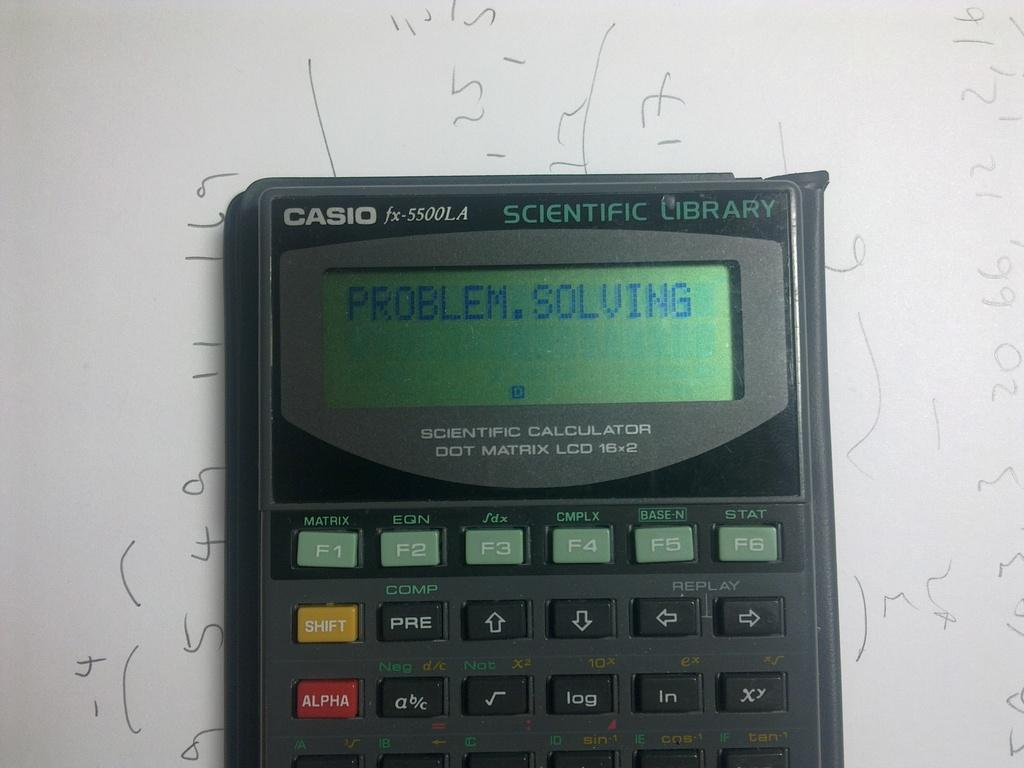<image>
Provide a brief description of the given image. A black Casio calculator over a piece of paper with math equations written on it. 